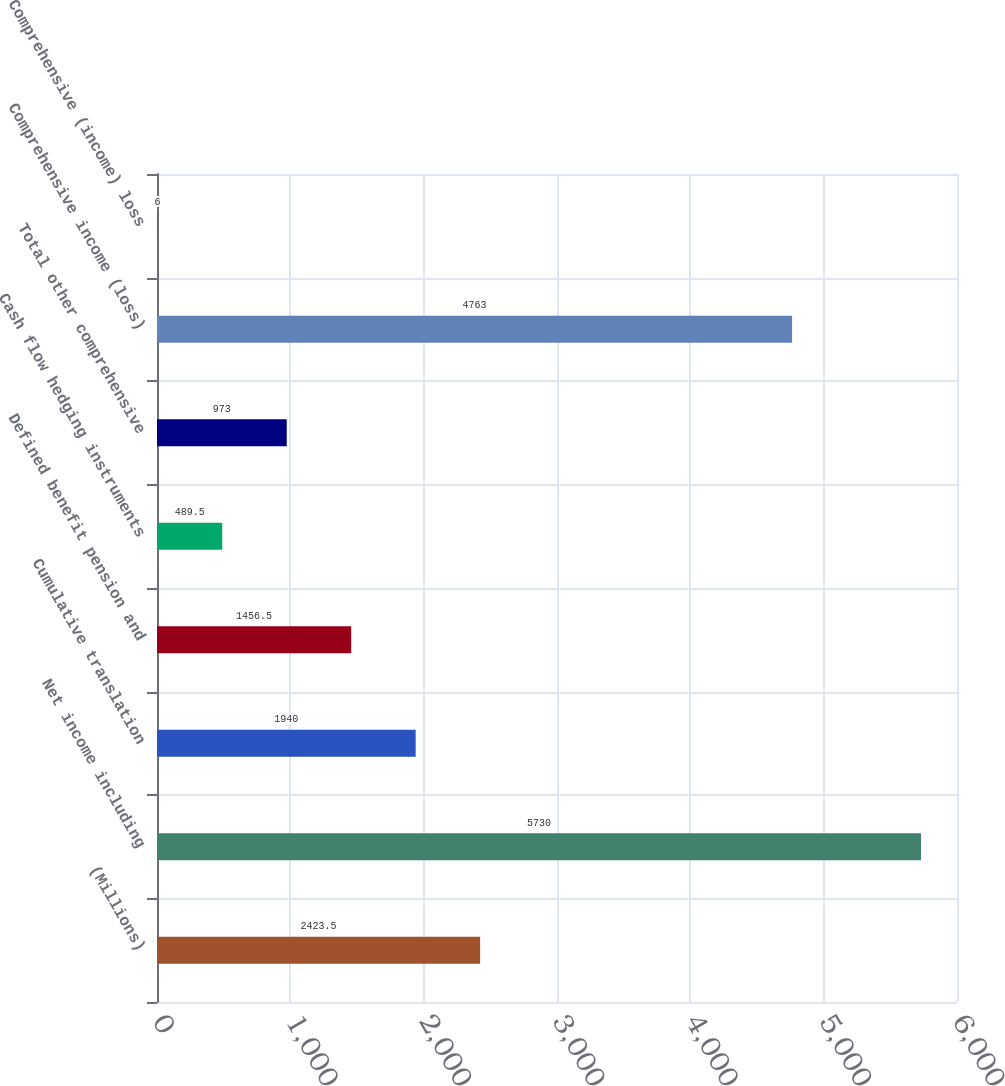<chart> <loc_0><loc_0><loc_500><loc_500><bar_chart><fcel>(Millions)<fcel>Net income including<fcel>Cumulative translation<fcel>Defined benefit pension and<fcel>Cash flow hedging instruments<fcel>Total other comprehensive<fcel>Comprehensive income (loss)<fcel>Comprehensive (income) loss<nl><fcel>2423.5<fcel>5730<fcel>1940<fcel>1456.5<fcel>489.5<fcel>973<fcel>4763<fcel>6<nl></chart> 